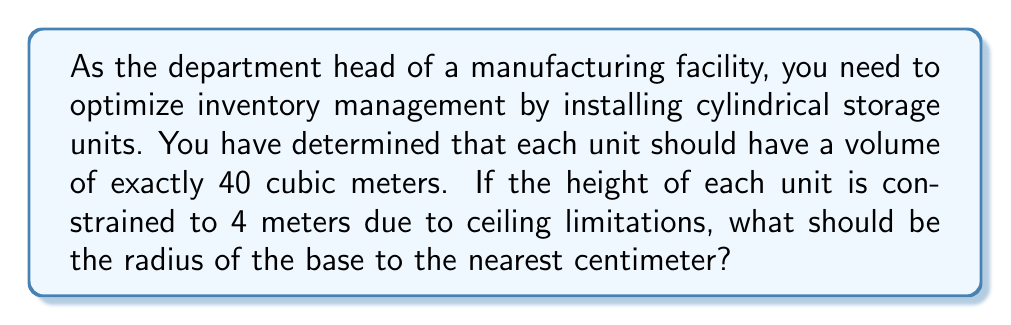Can you answer this question? Let's approach this step-by-step:

1) The volume of a cylinder is given by the formula:

   $$V = \pi r^2 h$$

   Where $V$ is volume, $r$ is radius, and $h$ is height.

2) We know that:
   - $V = 40$ m³ (desired volume)
   - $h = 4$ m (height constraint)

3) Substituting these values into the formula:

   $$40 = \pi r^2 (4)$$

4) Simplify:

   $$40 = 4\pi r^2$$

5) Divide both sides by $4\pi$:

   $$\frac{40}{4\pi} = r^2$$

6) Simplify:

   $$\frac{10}{\pi} = r^2$$

7) Take the square root of both sides:

   $$r = \sqrt{\frac{10}{\pi}}$$

8) Calculate the value (use a calculator for precision):

   $$r \approx 1.7841 \text{ m}$$

9) Convert to centimeters and round to the nearest centimeter:

   $$r \approx 178 \text{ cm}$$

Thus, the radius should be 178 cm to achieve the desired volume of 40 m³ with a height of 4 m.
Answer: The radius of the base should be 178 cm. 